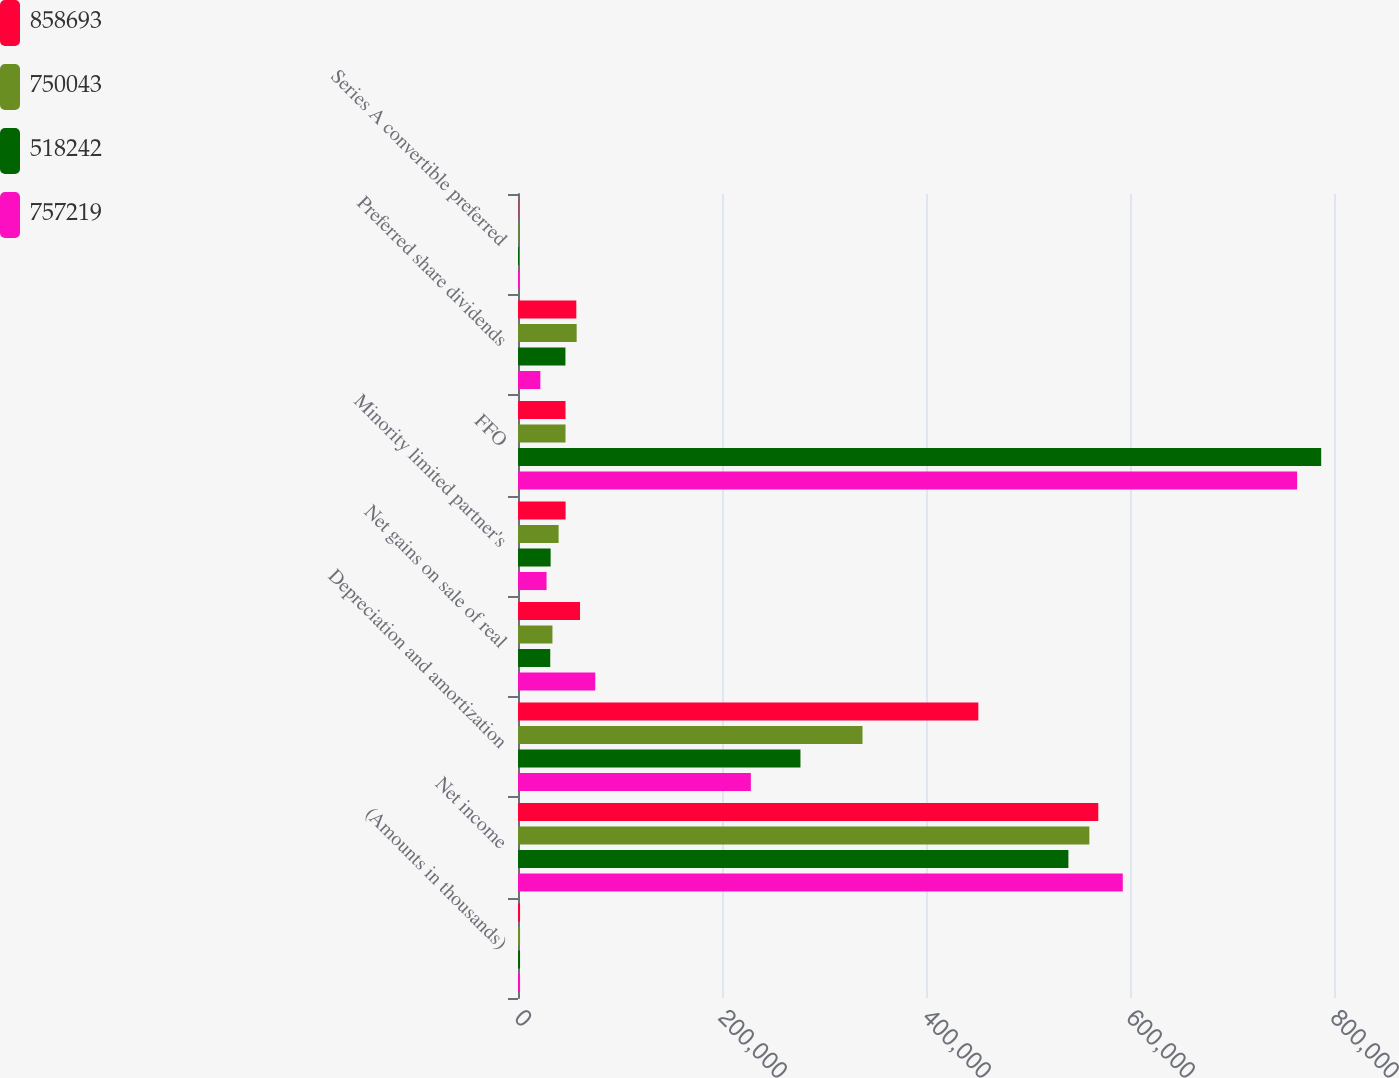<chart> <loc_0><loc_0><loc_500><loc_500><stacked_bar_chart><ecel><fcel>(Amounts in thousands)<fcel>Net income<fcel>Depreciation and amortization<fcel>Net gains on sale of real<fcel>Minority limited partner's<fcel>FFO<fcel>Preferred share dividends<fcel>Series A convertible preferred<nl><fcel>858693<fcel>2007<fcel>568906<fcel>451313<fcel>60811<fcel>46664<fcel>46582.5<fcel>57177<fcel>277<nl><fcel>750043<fcel>2006<fcel>560140<fcel>337730<fcel>33769<fcel>39809<fcel>46582.5<fcel>57511<fcel>631<nl><fcel>518242<fcel>2005<fcel>539604<fcel>276921<fcel>31614<fcel>31990<fcel>787442<fcel>46501<fcel>943<nl><fcel>757219<fcel>2004<fcel>592917<fcel>228298<fcel>75755<fcel>27991<fcel>763861<fcel>21920<fcel>1068<nl></chart> 